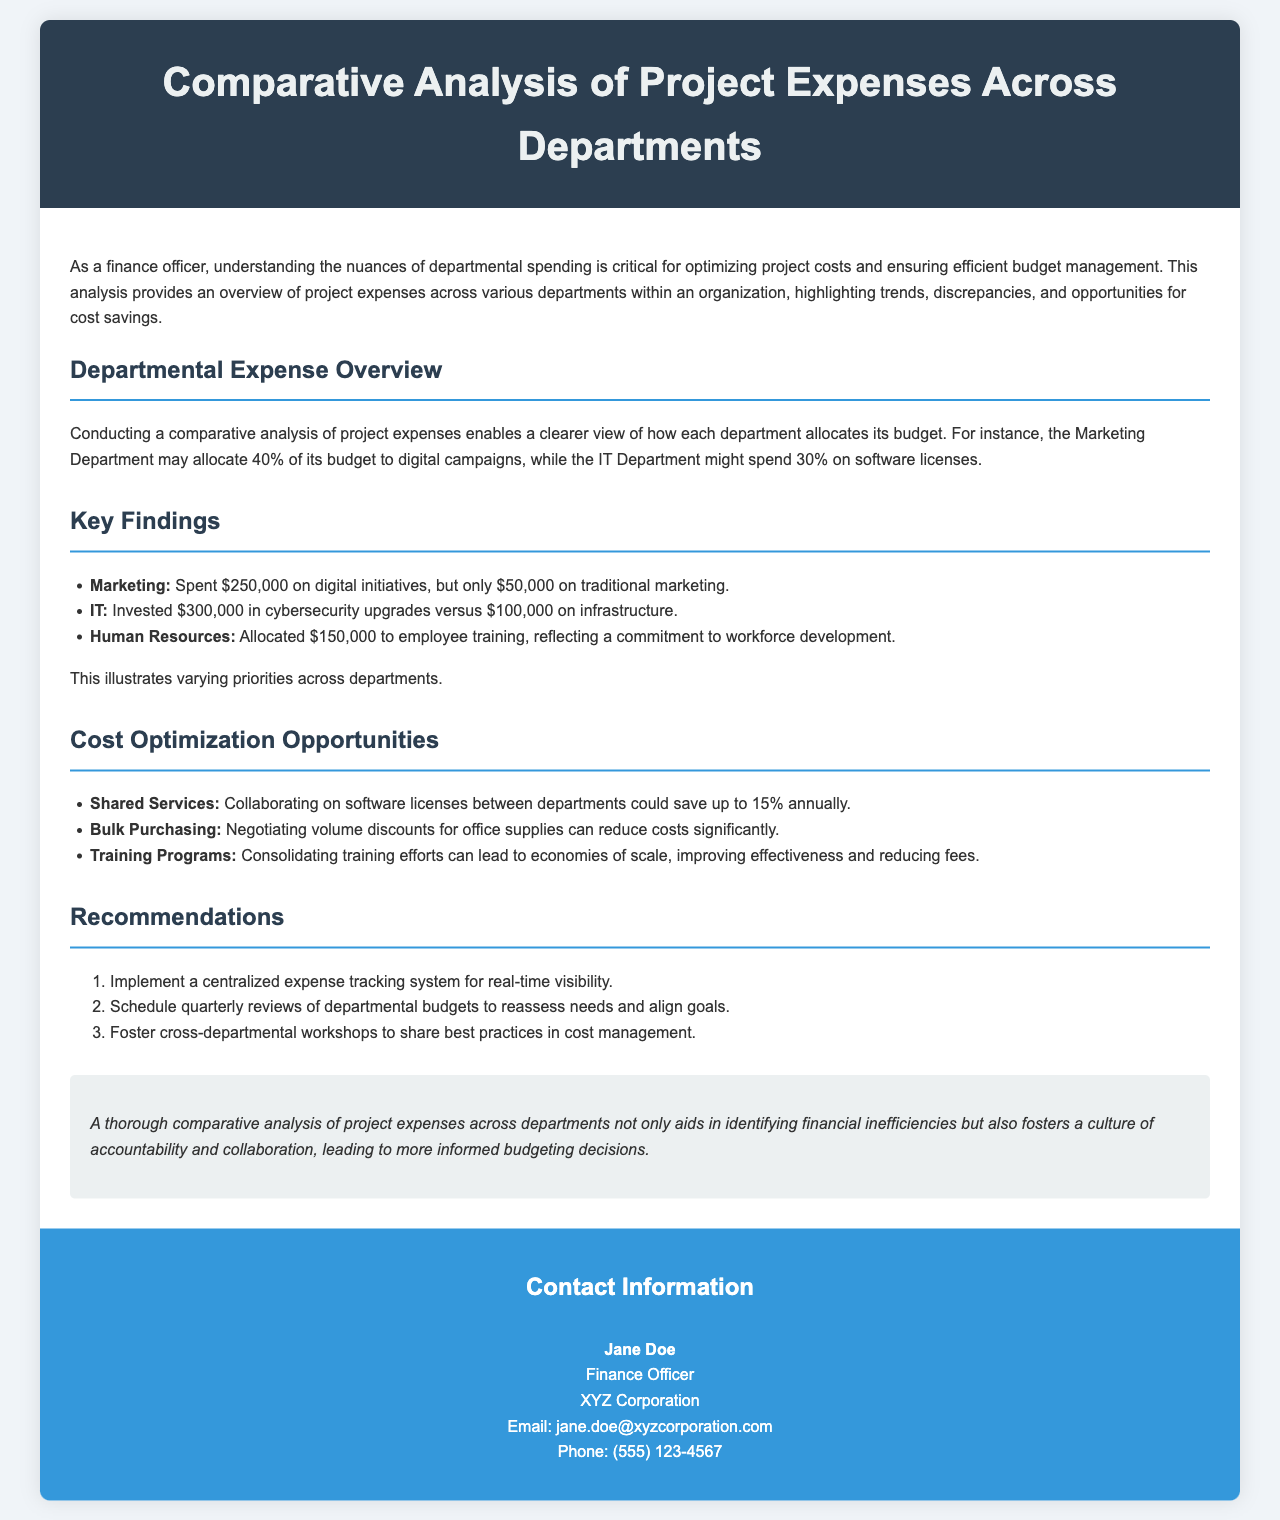What is the title of the brochure? The title is mentioned in the header section of the document.
Answer: Comparative Analysis of Project Expenses Across Departments How much did the Marketing Department spend on digital initiatives? The specific expenditures of the Marketing Department are listed under Key Findings.
Answer: $250,000 What percentage of the IT budget was spent on cybersecurity upgrades? The expenditures are described under Key Findings, giving insight into percentage allocations.
Answer: 75% What is one cost optimization opportunity mentioned? Several opportunities are listed in the Cost Optimization Opportunities section.
Answer: Shared Services Who is the contact person for the brochure? Contact information is provided in the Contact Information section.
Answer: Jane Doe What is the total amount spent by the IT Department on infrastructure? The IT Department’s spending details are summarized under Key Findings.
Answer: $100,000 What is a recommendation for improving budget management? Recommendations are outlined in the Recommendations section of the document.
Answer: Implement a centralized expense tracking system What percentage savings could be achieved through shared services? The potential savings are indicated in the Cost Optimization Opportunities section.
Answer: 15% What section discusses departmental spending? The analysis provides an overview of departmental spending in the Departmental Expense Overview.
Answer: Departmental Expense Overview 